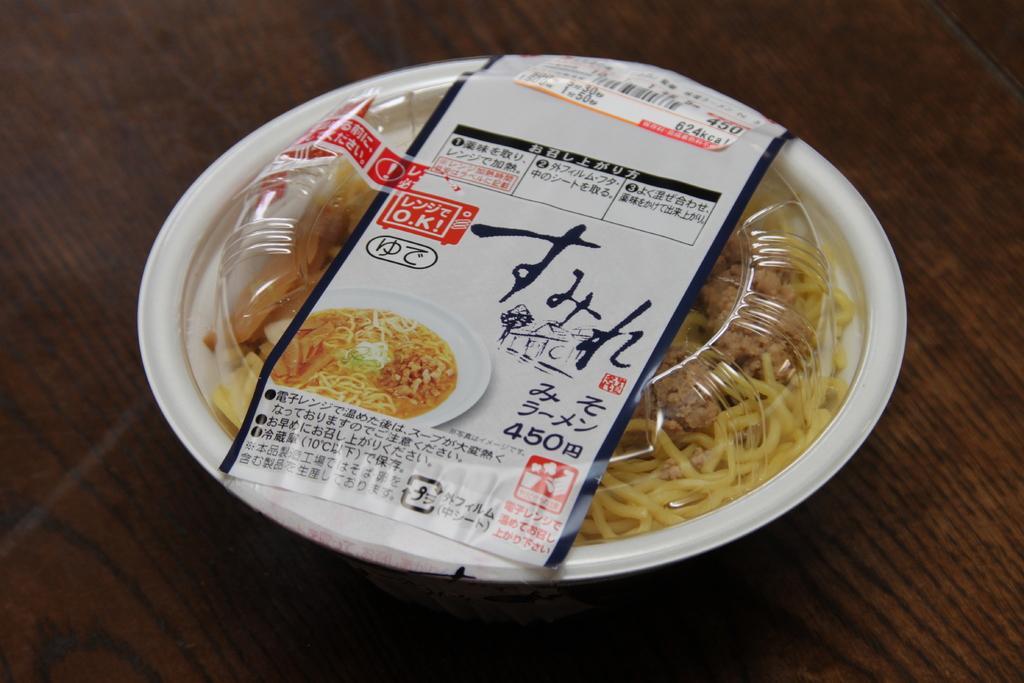Could you give a brief overview of what you see in this image? In this picture I can observe food box placed on the table. The table is in brown color. 